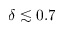<formula> <loc_0><loc_0><loc_500><loc_500>\delta \lesssim 0 . 7</formula> 